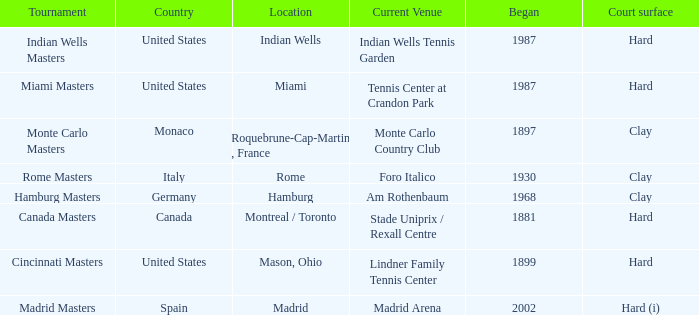Rome is in which country? Italy. 